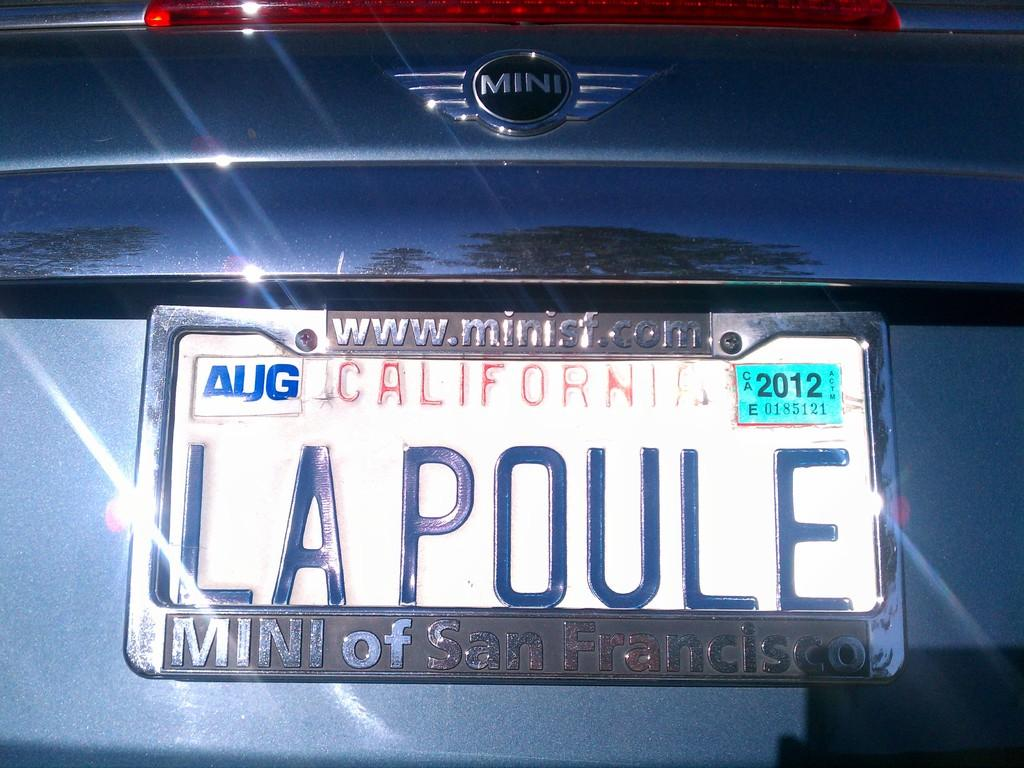<image>
Provide a brief description of the given image. A blue car that says Mini on the back has a California license plate. 